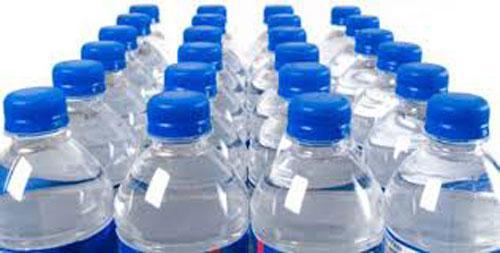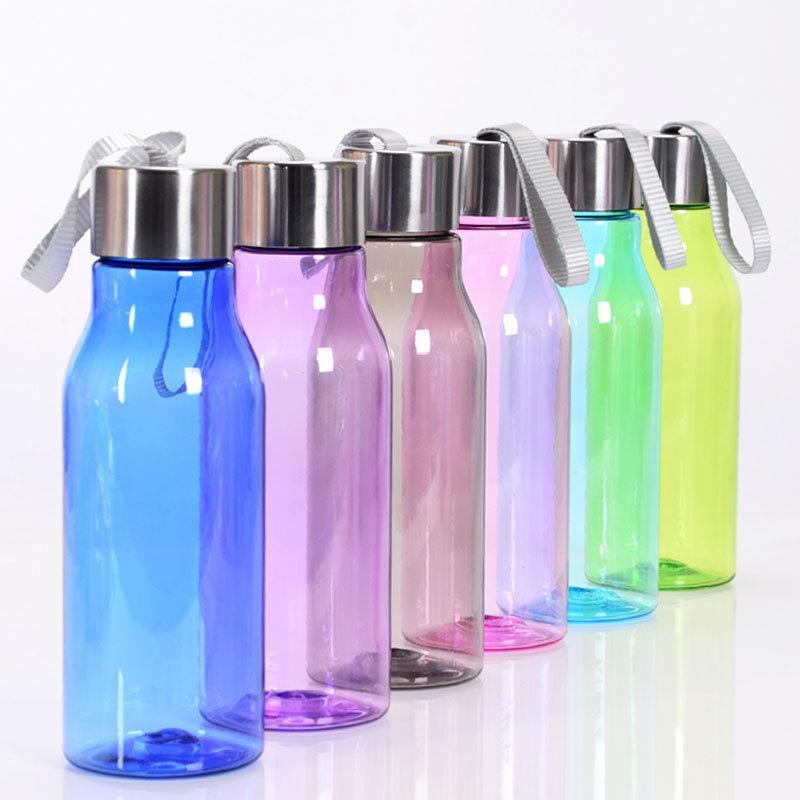The first image is the image on the left, the second image is the image on the right. Given the left and right images, does the statement "One of the images is of a single water bottle with a blue cap." hold true? Answer yes or no. No. 